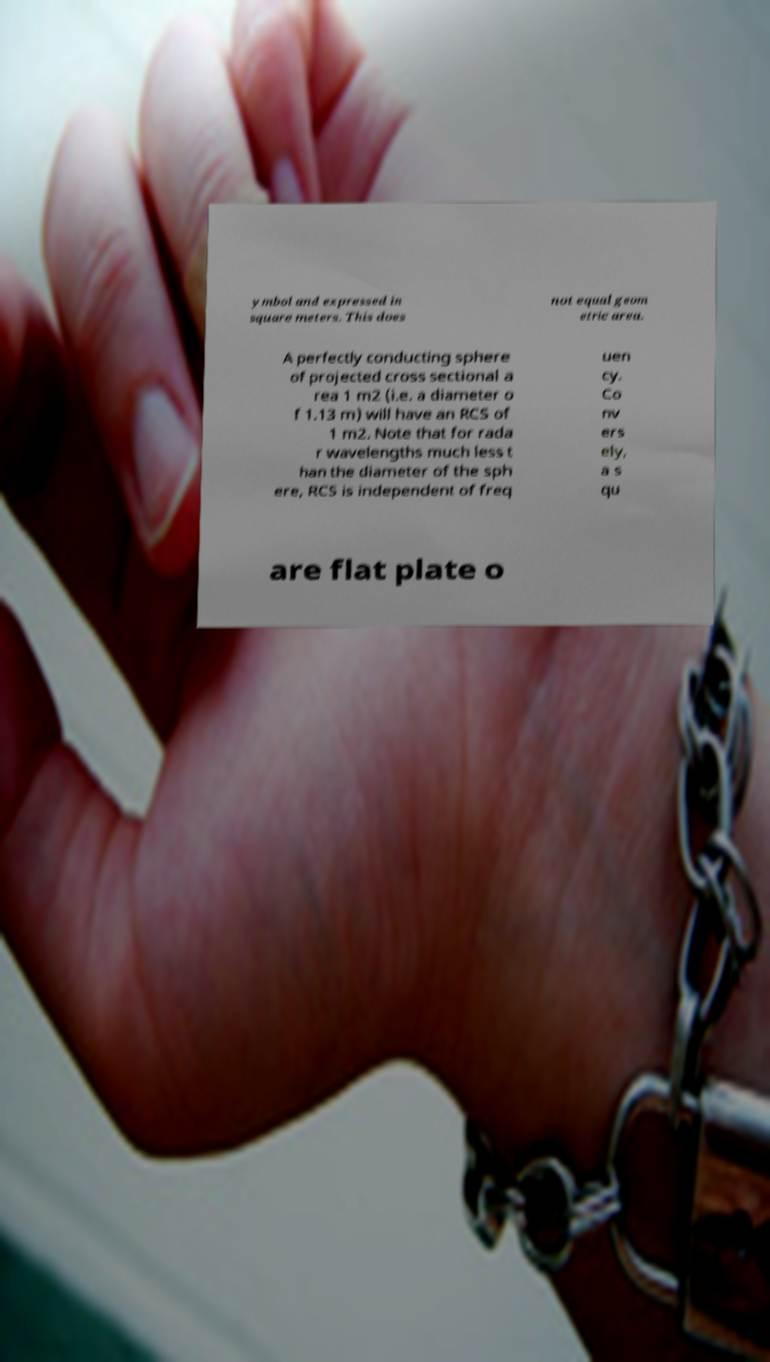For documentation purposes, I need the text within this image transcribed. Could you provide that? ymbol and expressed in square meters. This does not equal geom etric area. A perfectly conducting sphere of projected cross sectional a rea 1 m2 (i.e. a diameter o f 1.13 m) will have an RCS of 1 m2. Note that for rada r wavelengths much less t han the diameter of the sph ere, RCS is independent of freq uen cy. Co nv ers ely, a s qu are flat plate o 